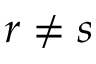Convert formula to latex. <formula><loc_0><loc_0><loc_500><loc_500>r \neq s</formula> 